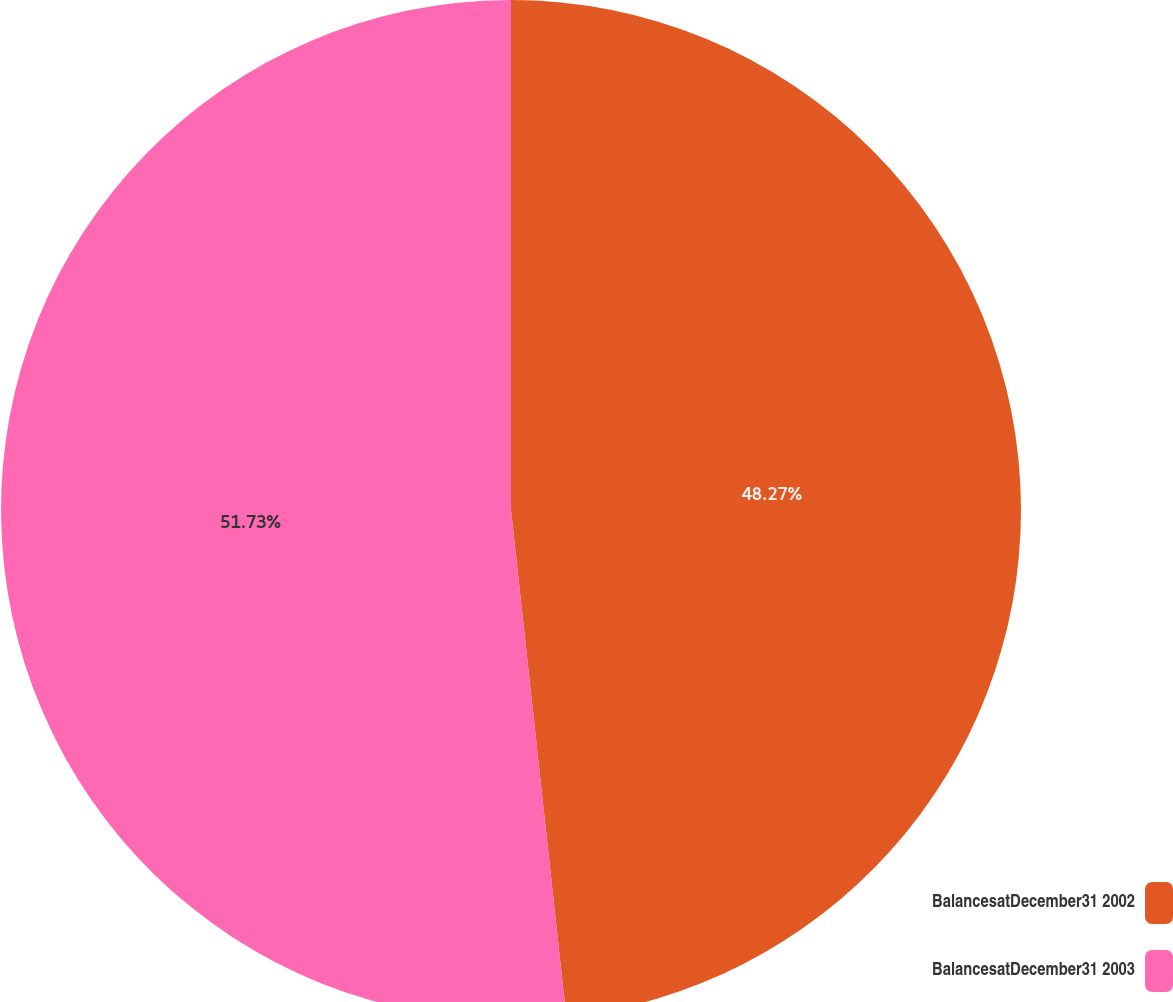Convert chart. <chart><loc_0><loc_0><loc_500><loc_500><pie_chart><fcel>BalancesatDecember31 2002<fcel>BalancesatDecember31 2003<nl><fcel>48.27%<fcel>51.73%<nl></chart> 